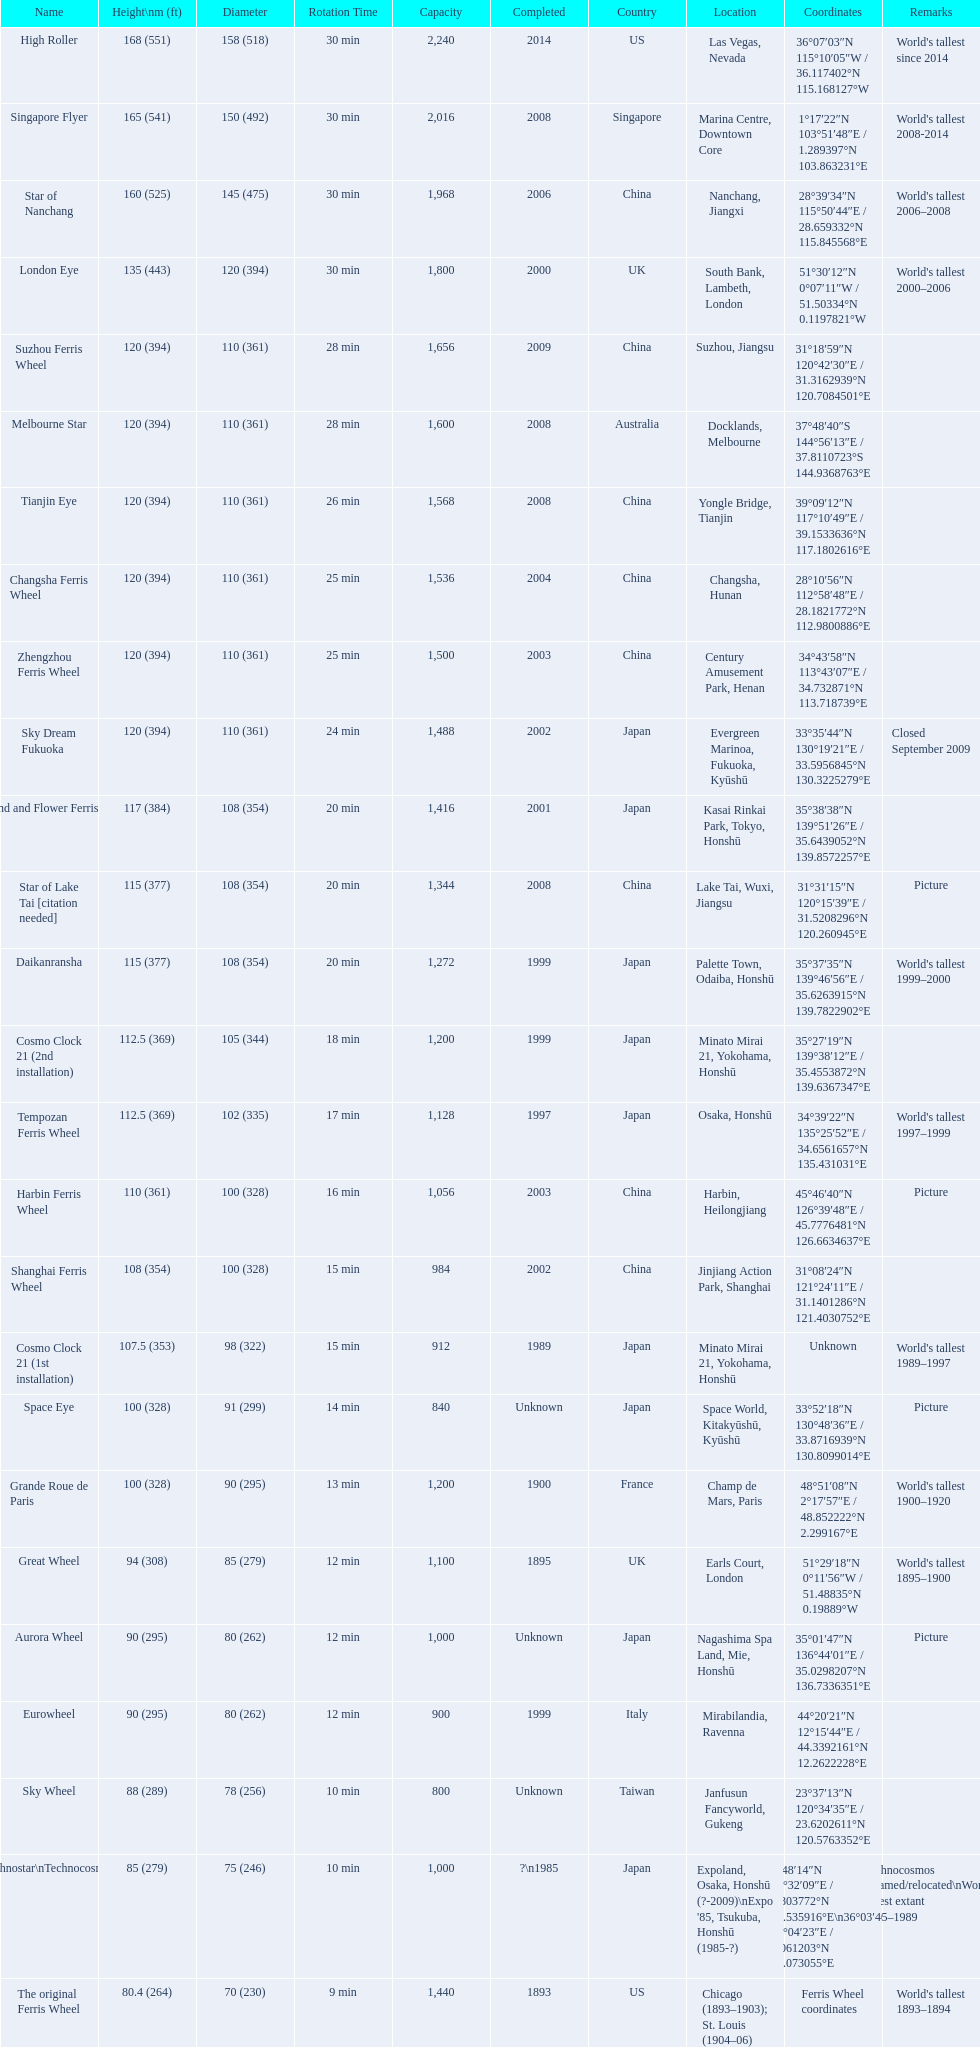What ferris wheels were completed in 2008 Singapore Flyer, Melbourne Star, Tianjin Eye, Star of Lake Tai [citation needed]. Of these, which has the height of 165? Singapore Flyer. 